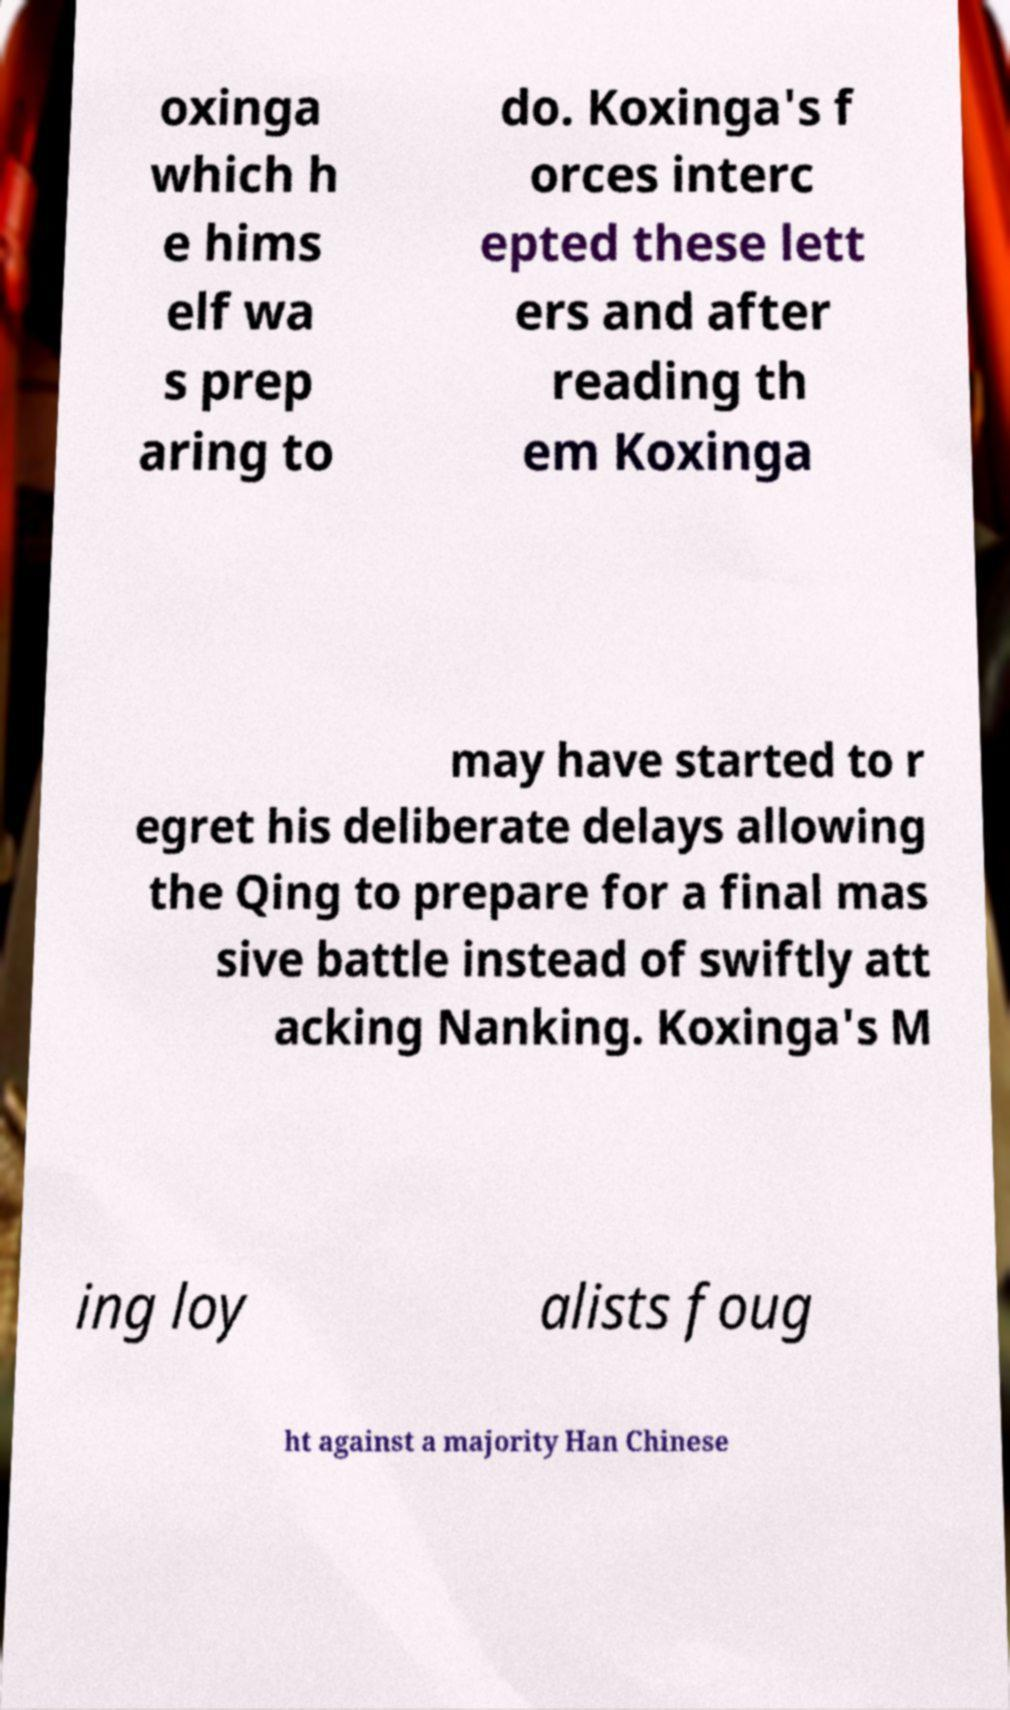I need the written content from this picture converted into text. Can you do that? oxinga which h e hims elf wa s prep aring to do. Koxinga's f orces interc epted these lett ers and after reading th em Koxinga may have started to r egret his deliberate delays allowing the Qing to prepare for a final mas sive battle instead of swiftly att acking Nanking. Koxinga's M ing loy alists foug ht against a majority Han Chinese 